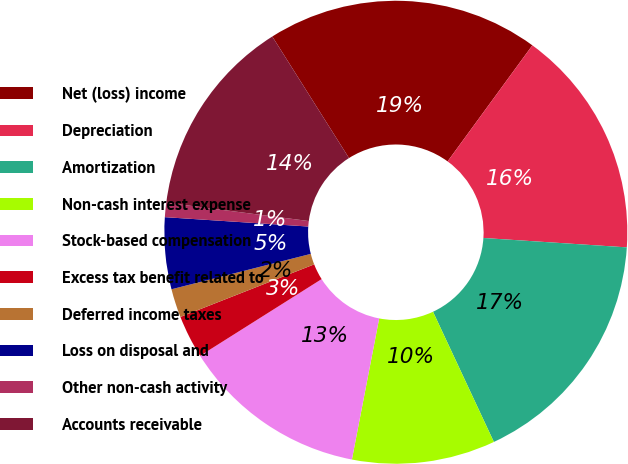<chart> <loc_0><loc_0><loc_500><loc_500><pie_chart><fcel>Net (loss) income<fcel>Depreciation<fcel>Amortization<fcel>Non-cash interest expense<fcel>Stock-based compensation<fcel>Excess tax benefit related to<fcel>Deferred income taxes<fcel>Loss on disposal and<fcel>Other non-cash activity<fcel>Accounts receivable<nl><fcel>19.0%<fcel>16.0%<fcel>17.0%<fcel>10.0%<fcel>13.0%<fcel>3.0%<fcel>2.0%<fcel>5.0%<fcel>1.0%<fcel>14.0%<nl></chart> 